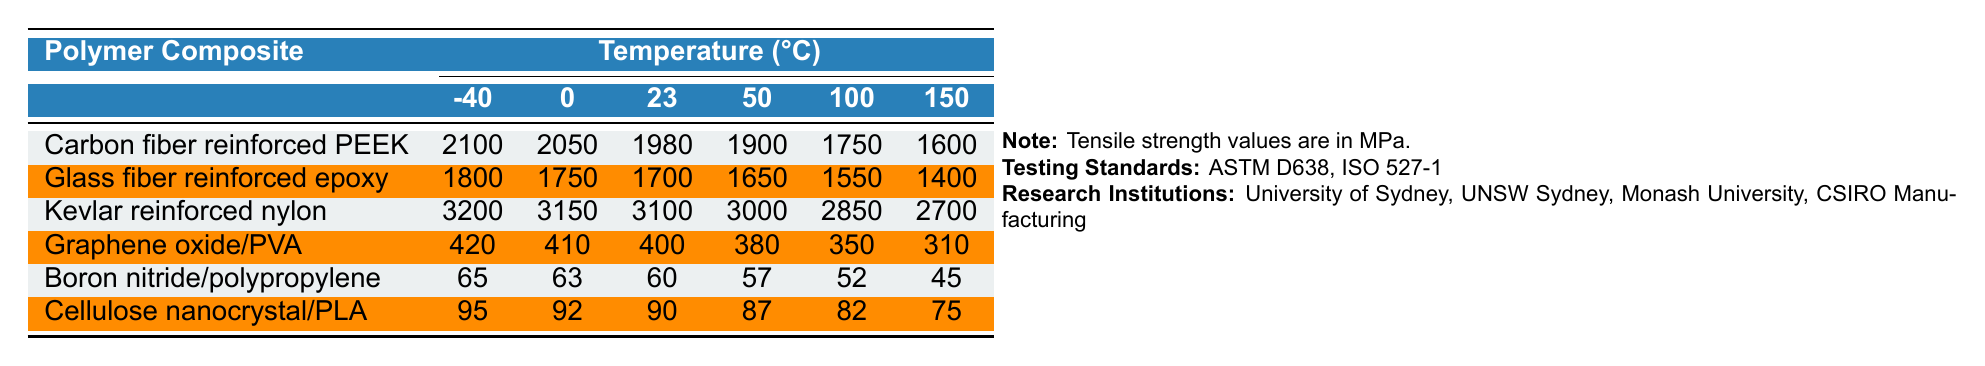What is the tensile strength of Kevlar reinforced nylon at 0°C? The table shows that the tensile strength of Kevlar reinforced nylon at 0°C is 3150 MPa.
Answer: 3150 MPa Which polymer composite has the highest tensile strength at 100°C? From the table, Kevlar reinforced nylon has the highest tensile strength at 100°C, which is 2850 MPa.
Answer: Kevlar reinforced nylon What is the tensile strength difference of Carbon fiber reinforced PEEK between -40°C and 50°C? The tensile strength at -40°C is 2100 MPa and at 50°C is 1900 MPa. The difference is 2100 - 1900 = 200 MPa.
Answer: 200 MPa What is the average tensile strength of Glass fiber reinforced epoxy across all temperatures? The tensile strengths are 1800, 1750, 1700, 1650, 1550, and 1400 MPa. Their sum is 1800 + 1750 + 1700 + 1650 + 1550 + 1400 = 10900 MPa. Dividing by 6 gives an average of 1816.67 MPa.
Answer: Approximately 1817 MPa Is the tensile strength of Graphene oxide/PVA ever above 400 MPa when temperatures increase? Reviewing the table, the tensile strength of Graphene oxide/PVA decreases with increasing temperature, starting at 420 MPa and dropping to 310 MPa at 150°C, confirming it is above 400 MPa only at -40°C and 0°C.
Answer: Yes Which polymer composite shows the least decrease in tensile strength from -40°C to 150°C? The differences in tensile strengths from -40°C to 150°C are 2100 to 1600 MPa for Carbon fiber reinforced PEEK, 1800 to 1400 MPa for Glass fiber reinforced epoxy, 3200 to 2700 MPa for Kevlar reinforced nylon, 420 to 310 MPa for Graphene oxide/PVA, 65 to 45 MPa for Boron nitride/polypropylene, and 95 to 75 MPa for Cellulose nanocrystal/PLA. The least decrease is 10 MPa, which corresponds to Cellulose nanocrystal/PLA.
Answer: Cellulose nanocrystal/PLA At what temperature does Boron nitride/polypropylene reach its lowest tensile strength? According to the table, Boron nitride/polypropylene reaches its lowest tensile strength of 45 MPa at 150°C.
Answer: 150°C How does the tensile strength of each polymer composite vary overall with temperature increase? The values generally show a trend of decreasing tensile strength with increasing temperature for all polymer composites listed in the table.
Answer: Generally decreases What is the tensile strength of Carbon fiber reinforced PEEK at the median temperature of 23°C? At 23°C, the tensile strength of Carbon fiber reinforced PEEK is found to be 1980 MPa, according to the table.
Answer: 1980 MPa Which polymer composite demonstrates the highest tensile strength at the lowest temperature of -40°C? The table indicates that Kevlar reinforced nylon exhibits the highest tensile strength at -40°C with a value of 3200 MPa.
Answer: Kevlar reinforced nylon 